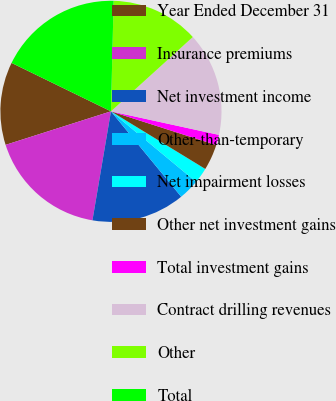Convert chart. <chart><loc_0><loc_0><loc_500><loc_500><pie_chart><fcel>Year Ended December 31<fcel>Insurance premiums<fcel>Net investment income<fcel>Other-than-temporary<fcel>Net impairment losses<fcel>Other net investment gains<fcel>Total investment gains<fcel>Contract drilling revenues<fcel>Other<fcel>Total<nl><fcel>12.12%<fcel>17.42%<fcel>13.63%<fcel>3.04%<fcel>2.28%<fcel>3.79%<fcel>1.52%<fcel>15.15%<fcel>12.88%<fcel>18.17%<nl></chart> 